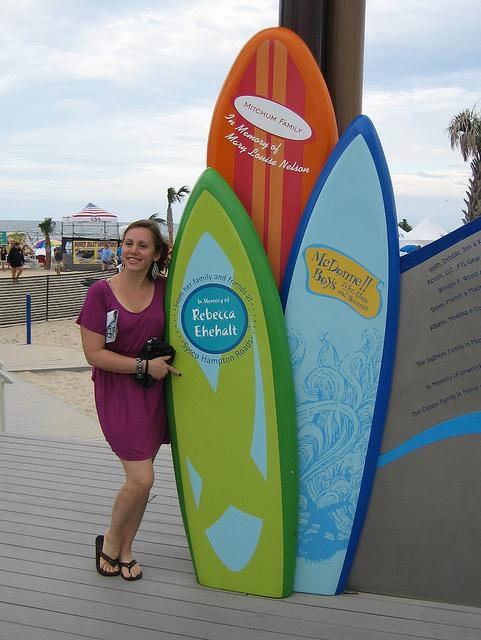How many surfboards are there?
Quick response, please. 3. Is the board white?
Give a very brief answer. No. What color is the sign?
Answer briefly. Green. What color dress is she wearing?
Write a very short answer. Purple. Will she go surfing now?
Give a very brief answer. No. What color is the surfboard?
Give a very brief answer. Green. 